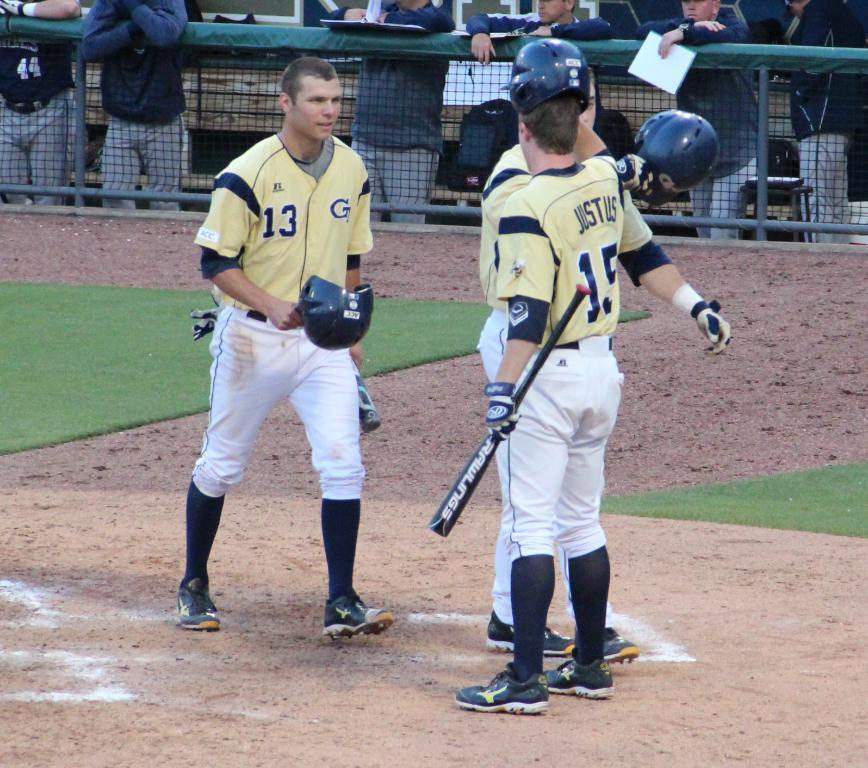<image>
Provide a brief description of the given image. Baseball players, Number 15 has Just Us on the back of his shirt. 